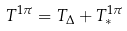<formula> <loc_0><loc_0><loc_500><loc_500>T ^ { 1 \pi } = T _ { \Delta } + T ^ { 1 \pi } _ { * }</formula> 